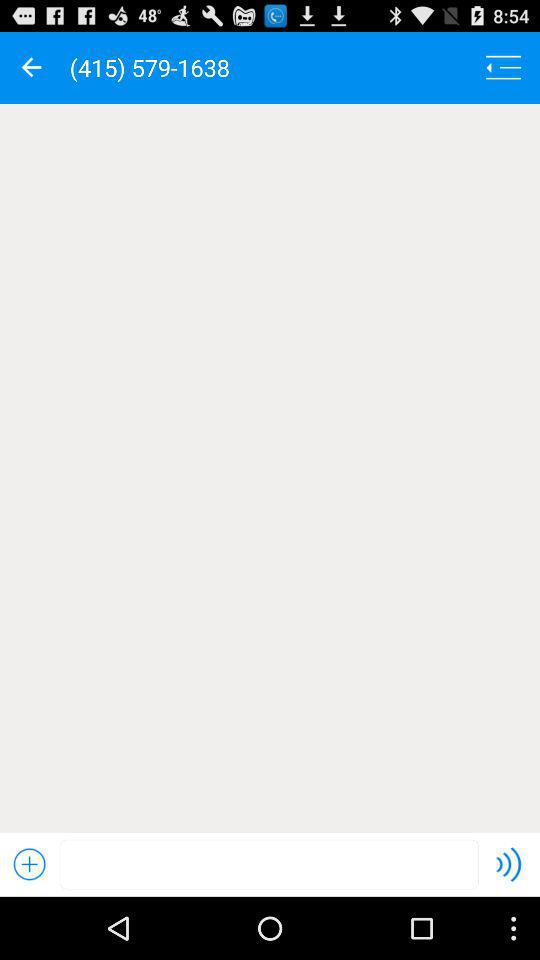What is the contact number shown on the screen? The contact number is (415) 579-1638. 